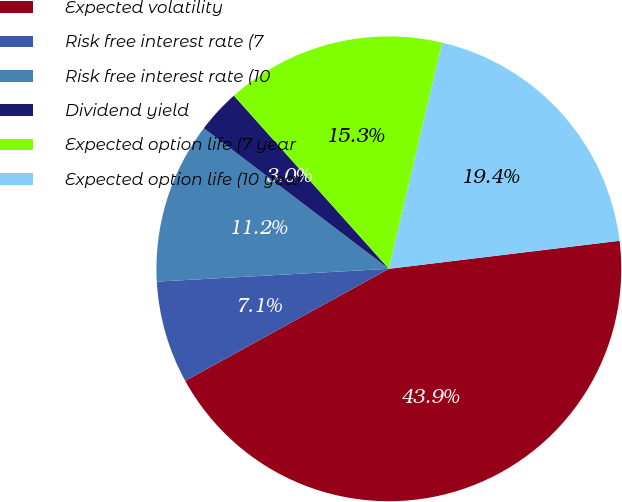<chart> <loc_0><loc_0><loc_500><loc_500><pie_chart><fcel>Expected volatility<fcel>Risk free interest rate (7<fcel>Risk free interest rate (10<fcel>Dividend yield<fcel>Expected option life (7 year<fcel>Expected option life (10 year<nl><fcel>43.91%<fcel>7.13%<fcel>11.22%<fcel>3.04%<fcel>15.3%<fcel>19.39%<nl></chart> 